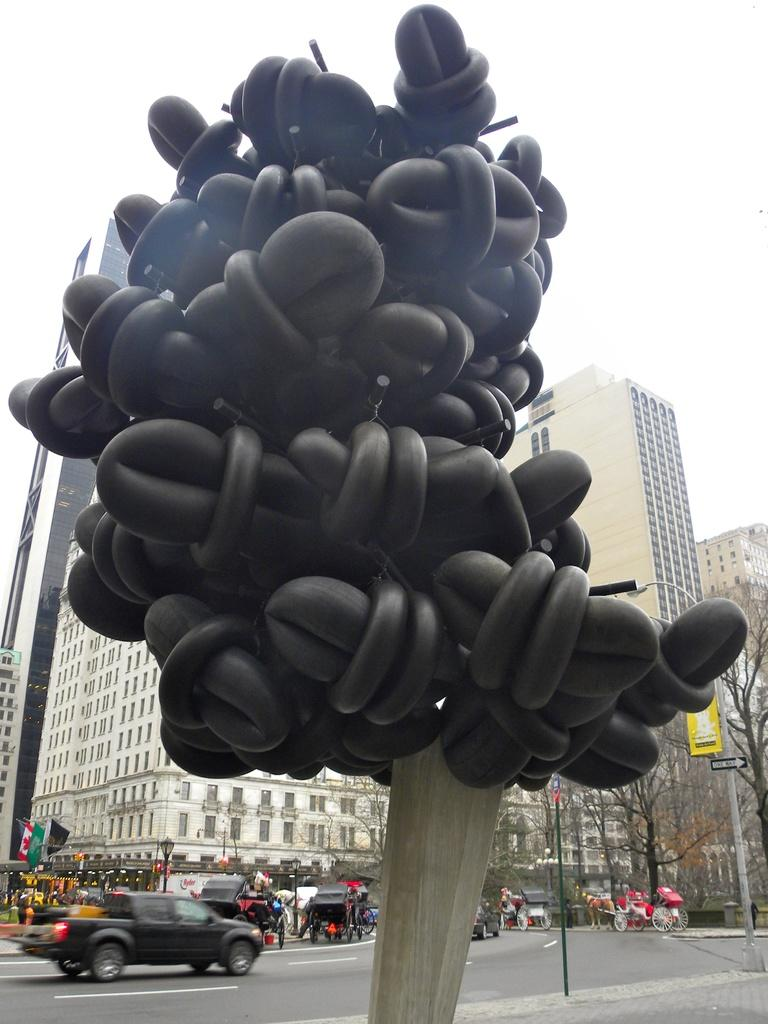What is the main subject in the center of the image? There is a sculpture in the center of the image. What can be seen at the bottom of the image? There are vehicles on the road at the bottom of the image. What is visible in the background of the image? Buildings, trees, poles, flags, boards, and people are visible in the background of the image. What part of the natural environment is visible in the image? The sky is visible in the background of the image. How many mice are running on the sculpture in the image? There are no mice present in the image, and therefore no such activity can be observed. 